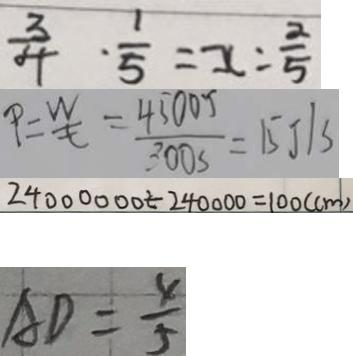Convert formula to latex. <formula><loc_0><loc_0><loc_500><loc_500>\frac { 3 } { 4 } \cdot \frac { 1 } { 5 } = x : \frac { 2 } { 5 } 
 P = \frac { W } { t } = \frac { 4 5 0 0 J } { 3 0 0 S } = 1 5 J / S 
 2 4 0 0 0 0 0 0 \div 2 4 0 0 0 0 0 = 1 0 0 ( c m ) 
 A D = \frac { 4 } { 5 }</formula> 